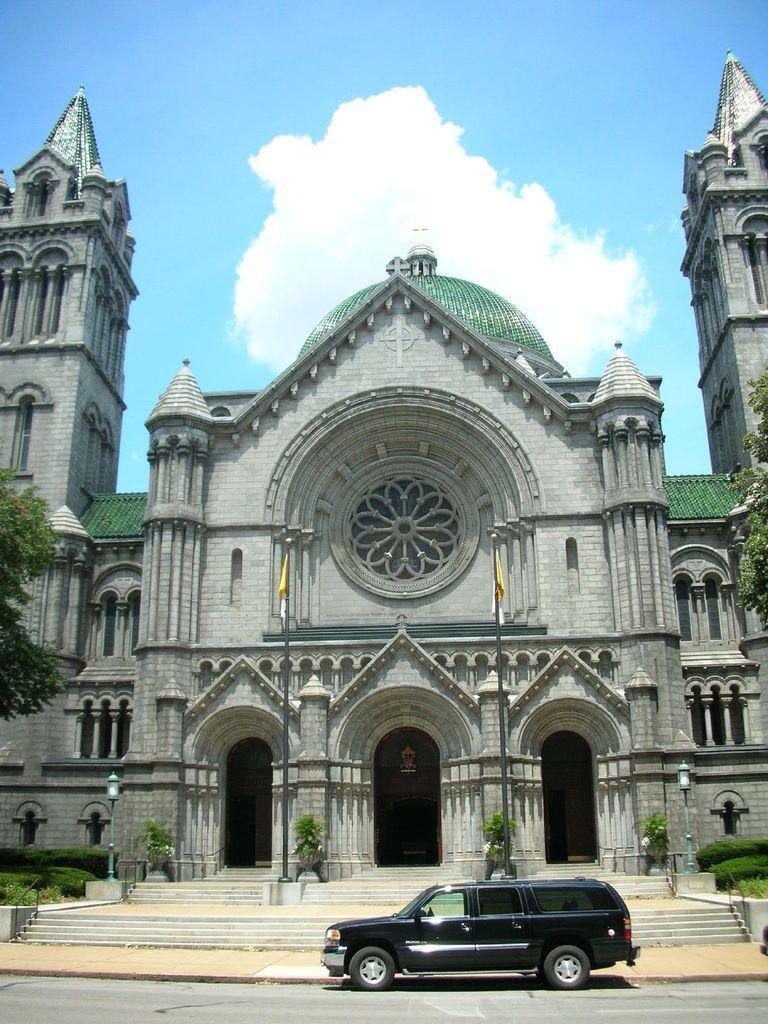Can you describe this image briefly? In the center of the image there is a car on the road. In the background of the image there is a building. There are trees to both sides of the image. To the top of the image there is sky and clouds. 